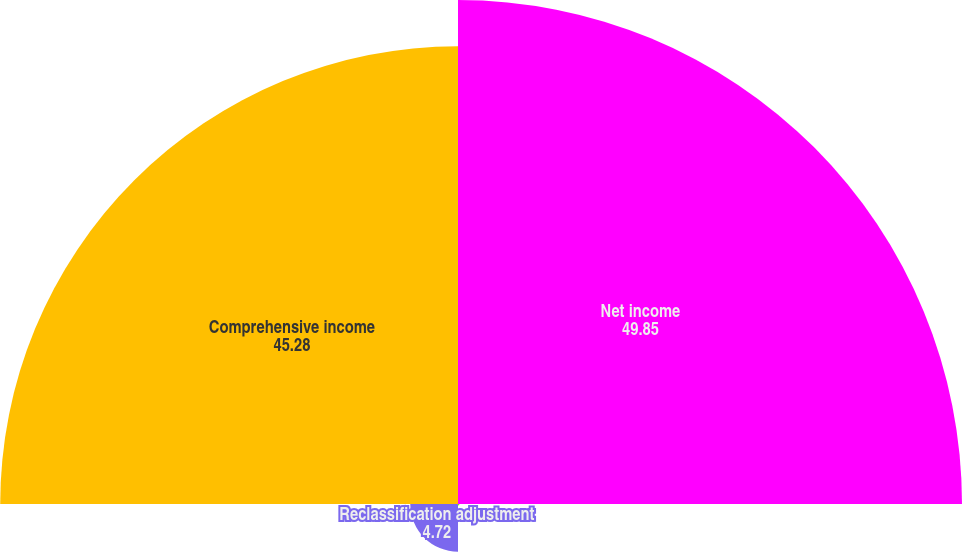Convert chart to OTSL. <chart><loc_0><loc_0><loc_500><loc_500><pie_chart><fcel>Net income<fcel>Unrealized (loss) gain from<fcel>Reclassification adjustment<fcel>Comprehensive income<nl><fcel>49.85%<fcel>0.15%<fcel>4.72%<fcel>45.28%<nl></chart> 